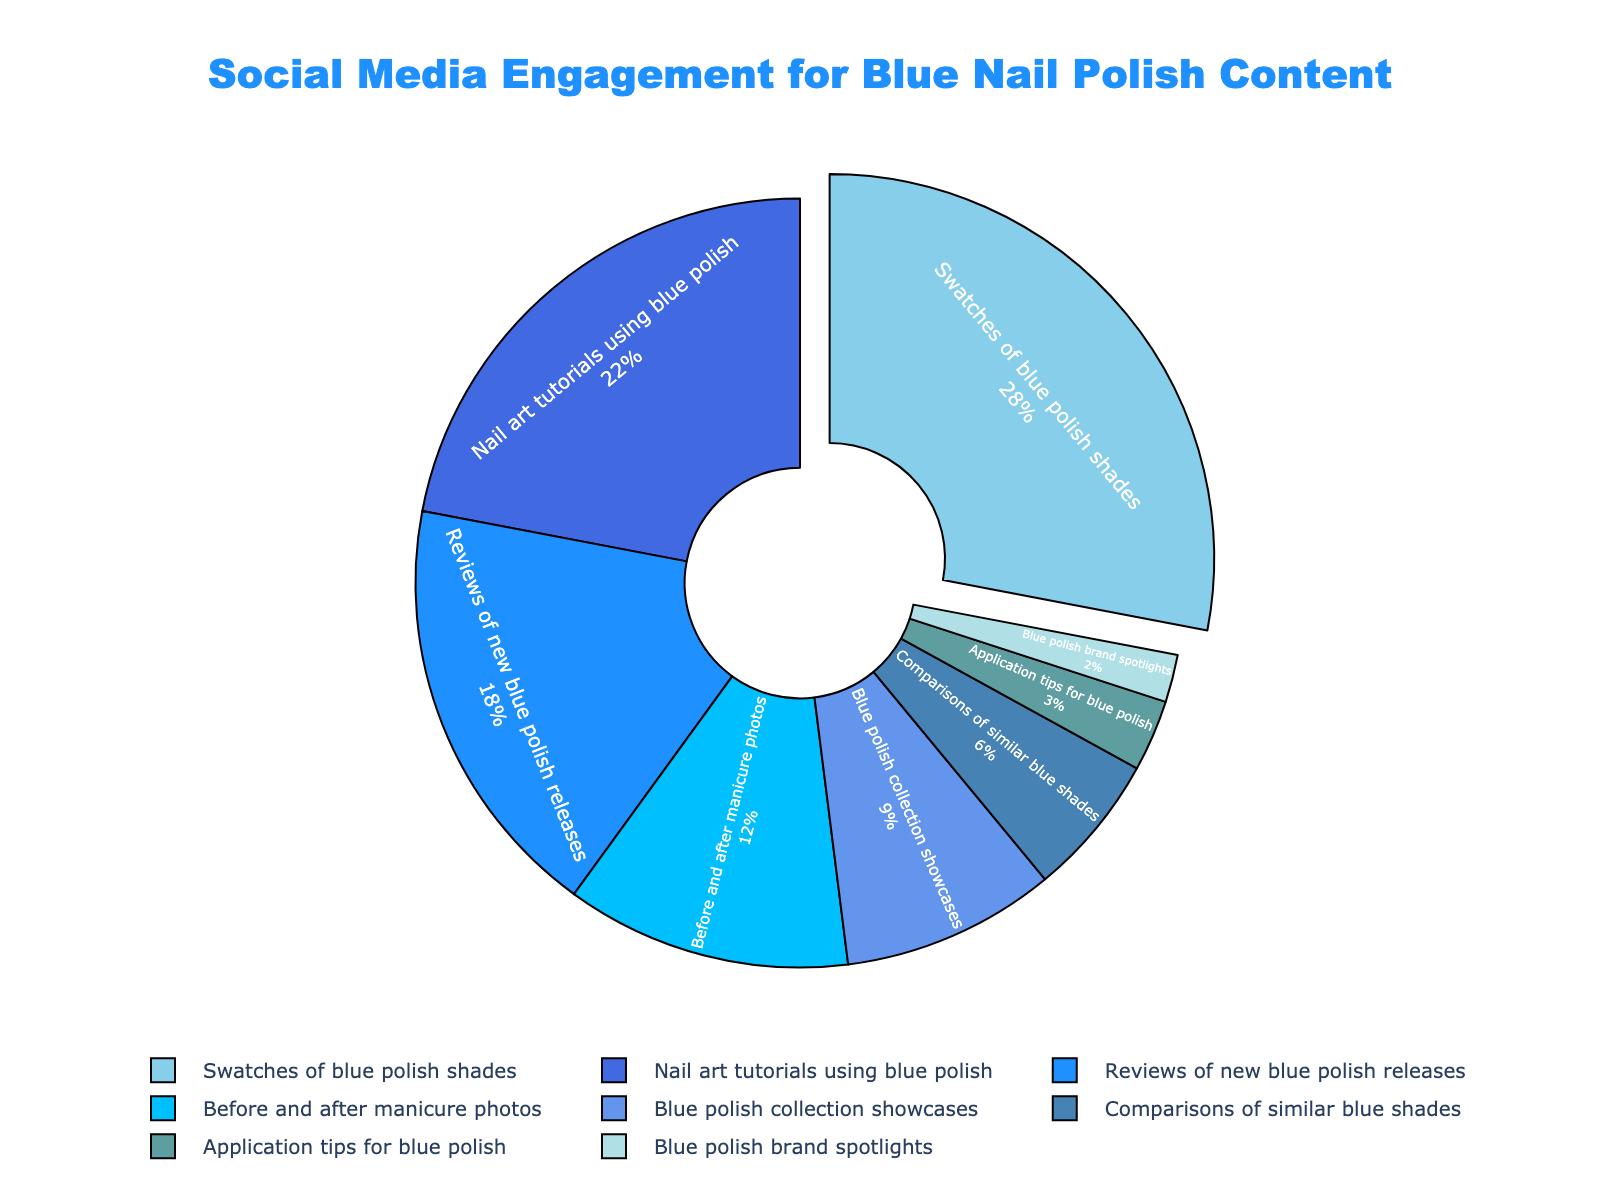What percent of engagement comes from swatches of blue nail polish shades? The engagement percentage for swatches of blue polish shades can be directly read from the pie chart. It is labeled as 28%.
Answer: 28% Which category has the lowest engagement percentage? Look at the pie chart and identify the smallest segment, which is labeled as "Blue polish brand spotlights" with a 2% engagement.
Answer: Blue polish brand spotlights What is the combined engagement percentage of "Comparisons of similar blue shades" and "Application tips for blue polish"? To find the combined engagement percentage, add the engagement percentages of these two categories: 6% + 3% = 9%.
Answer: 9% How much higher is the engagement for "Nail art tutorials using blue polish" compared to "Blue polish collection showcases"? Subtract the engagement percentage of "Blue polish collection showcases" (9%) from "Nail art tutorials using blue polish" (22%): 22% - 9% = 13%.
Answer: 13% What percentage of engagement is for content other than "Nail art tutorials using blue polish"? Subtract the percentage of "Nail art tutorials using blue polish" (22%) from the total percentage (100%): 100% - 22% = 78%.
Answer: 78% Among the categories with engagement percentages in single digits, which has the highest percentage? Compare the engagement percentages of categories with single-digit values: "Blue polish collection showcases" (9%), "Comparisons of similar blue shades" (6%), "Application tips for blue polish" (3%), and "Blue polish brand spotlights" (2%). The highest is "Blue polish collection showcases" with 9%.
Answer: Blue polish collection showcases What is the average engagement percentage for "Swatches of blue polish shades", "Nail art tutorials using blue polish", and "Reviews of new blue polish releases"? Add the engagement percentages for these categories: 28% + 22% + 18% = 68%. Then divide by the number of categories: 68% / 3 = 22.67%.
Answer: 22.67% Which category has a larger engagement percentage: "Reviews of new blue polish releases" or "Before and after" manicure photos? Compare the engagement percentages directly from the chart: "Reviews of new blue polish releases" has 18% while "Before and after" manicure photos have 12%. Therefore, 18% is larger than 12%.
Answer: Reviews of new blue polish releases 